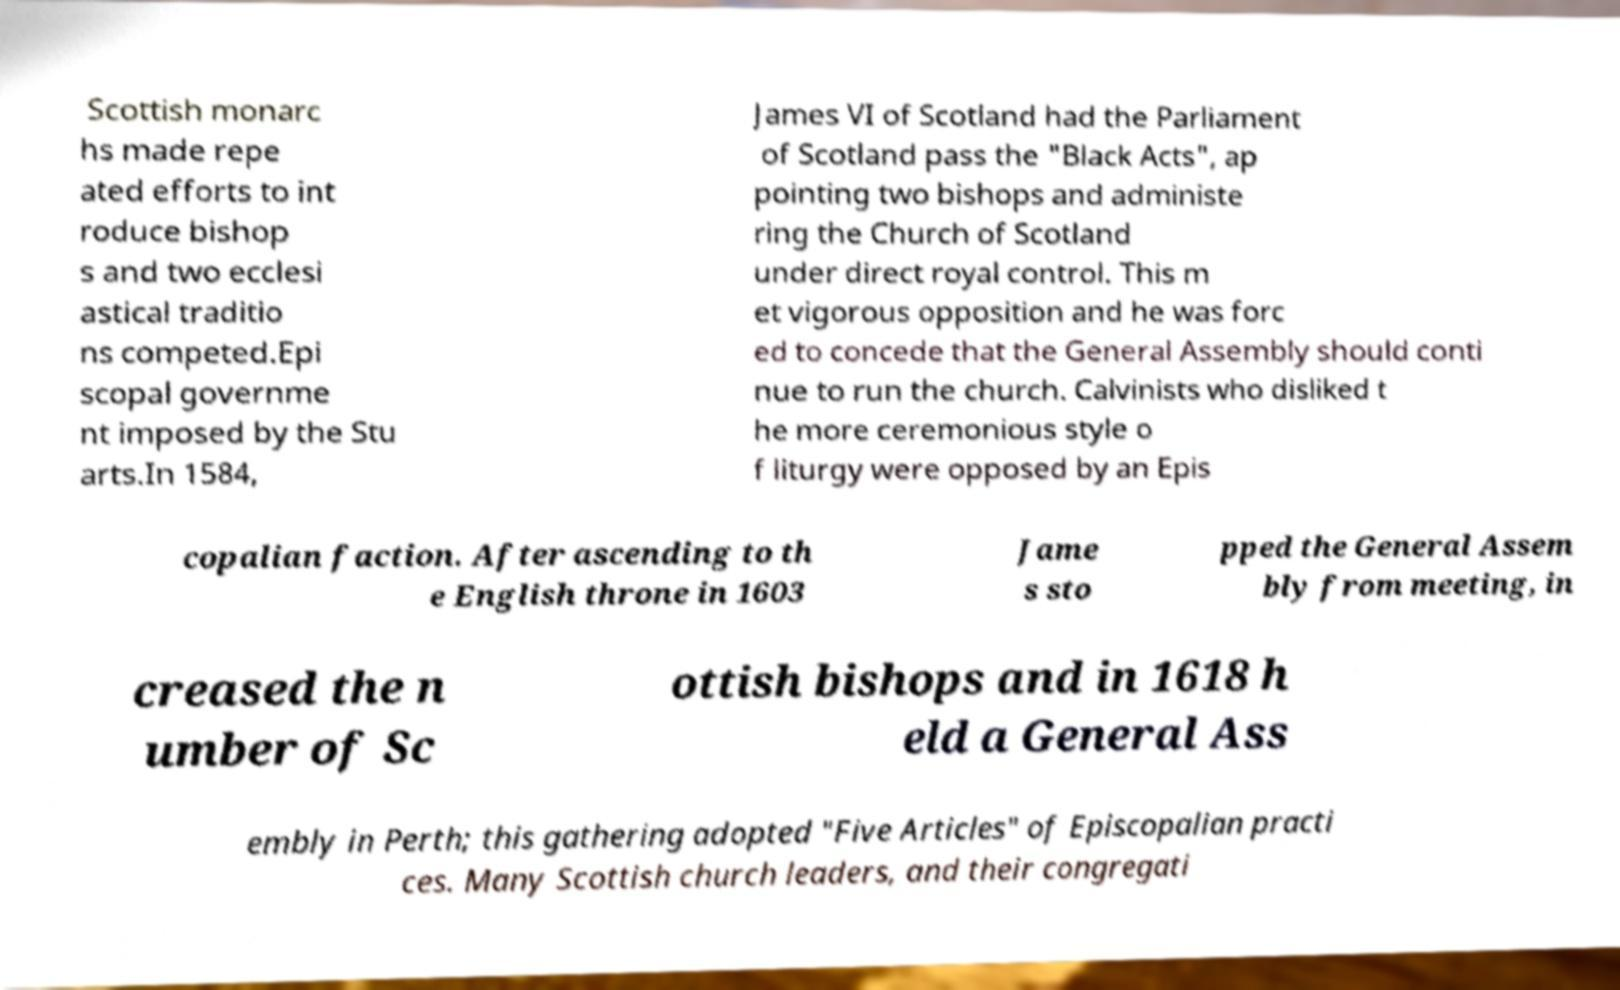Please read and relay the text visible in this image. What does it say? Scottish monarc hs made repe ated efforts to int roduce bishop s and two ecclesi astical traditio ns competed.Epi scopal governme nt imposed by the Stu arts.In 1584, James VI of Scotland had the Parliament of Scotland pass the "Black Acts", ap pointing two bishops and administe ring the Church of Scotland under direct royal control. This m et vigorous opposition and he was forc ed to concede that the General Assembly should conti nue to run the church. Calvinists who disliked t he more ceremonious style o f liturgy were opposed by an Epis copalian faction. After ascending to th e English throne in 1603 Jame s sto pped the General Assem bly from meeting, in creased the n umber of Sc ottish bishops and in 1618 h eld a General Ass embly in Perth; this gathering adopted "Five Articles" of Episcopalian practi ces. Many Scottish church leaders, and their congregati 